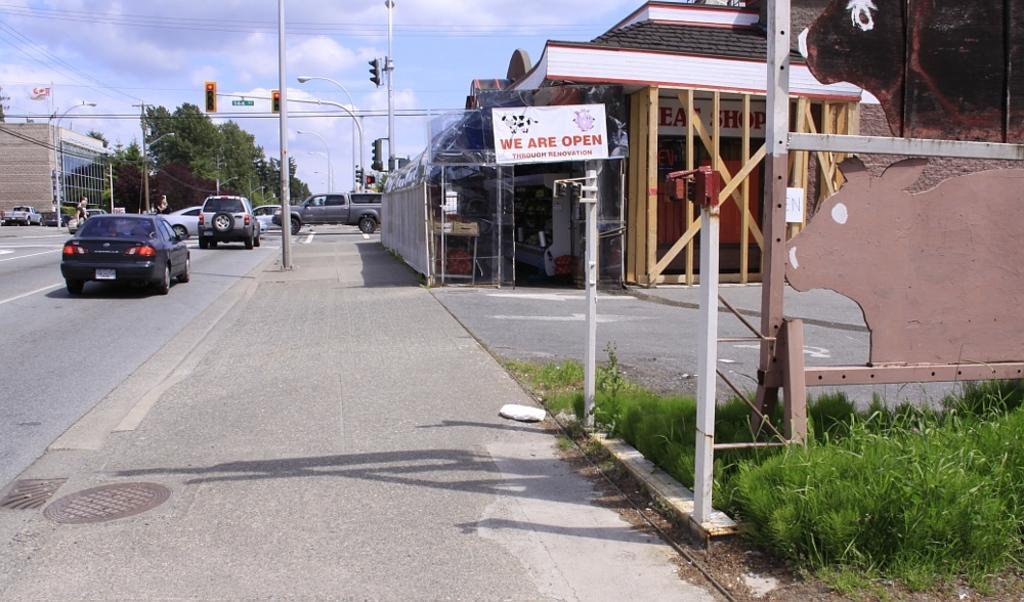Please provide a concise description of this image. In this image there is a person, vehicles on the road, buildings, signal lights , board and lights attached to the poles, and at the background there are buildings , grass, trees,flag,sky. 